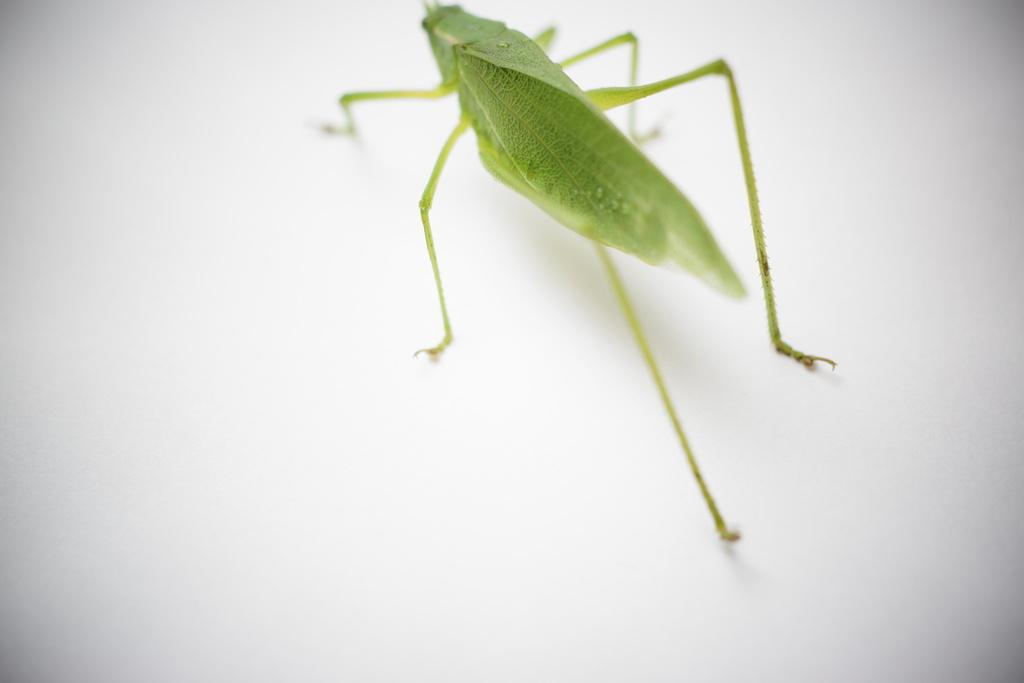What is the main subject of the picture? There is a grasshopper in the picture. What color is the background of the image? The background of the image is white. Has the image been altered in any way? Yes, the image has been edited. What joke did the grasshopper's brother tell in the image? There is no reference to a joke or a brother in the image, so it is not possible to answer that question. 